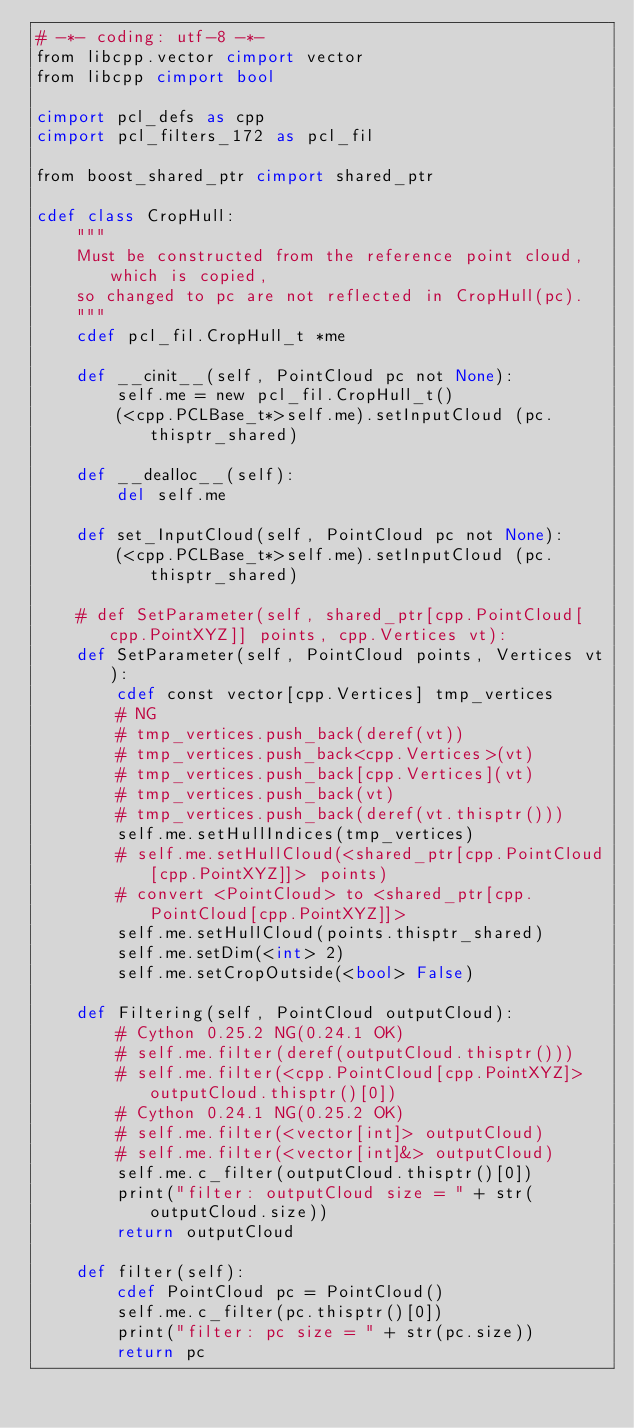<code> <loc_0><loc_0><loc_500><loc_500><_Cython_># -*- coding: utf-8 -*-
from libcpp.vector cimport vector
from libcpp cimport bool

cimport pcl_defs as cpp
cimport pcl_filters_172 as pcl_fil

from boost_shared_ptr cimport shared_ptr

cdef class CropHull:
    """
    Must be constructed from the reference point cloud, which is copied, 
    so changed to pc are not reflected in CropHull(pc).
    """
    cdef pcl_fil.CropHull_t *me

    def __cinit__(self, PointCloud pc not None):
        self.me = new pcl_fil.CropHull_t()
        (<cpp.PCLBase_t*>self.me).setInputCloud (pc.thisptr_shared)

    def __dealloc__(self):
        del self.me

    def set_InputCloud(self, PointCloud pc not None):
        (<cpp.PCLBase_t*>self.me).setInputCloud (pc.thisptr_shared)

    # def SetParameter(self, shared_ptr[cpp.PointCloud[cpp.PointXYZ]] points, cpp.Vertices vt):
    def SetParameter(self, PointCloud points, Vertices vt):
        cdef const vector[cpp.Vertices] tmp_vertices
        # NG
        # tmp_vertices.push_back(deref(vt))
        # tmp_vertices.push_back<cpp.Vertices>(vt)
        # tmp_vertices.push_back[cpp.Vertices](vt)
        # tmp_vertices.push_back(vt)
        # tmp_vertices.push_back(deref(vt.thisptr()))
        self.me.setHullIndices(tmp_vertices)
        # self.me.setHullCloud(<shared_ptr[cpp.PointCloud[cpp.PointXYZ]]> points)
        # convert <PointCloud> to <shared_ptr[cpp.PointCloud[cpp.PointXYZ]]>
        self.me.setHullCloud(points.thisptr_shared)
        self.me.setDim(<int> 2)
        self.me.setCropOutside(<bool> False)

    def Filtering(self, PointCloud outputCloud):
        # Cython 0.25.2 NG(0.24.1 OK)
        # self.me.filter(deref(outputCloud.thisptr()))
        # self.me.filter(<cpp.PointCloud[cpp.PointXYZ]> outputCloud.thisptr()[0])
        # Cython 0.24.1 NG(0.25.2 OK)
        # self.me.filter(<vector[int]> outputCloud)
        # self.me.filter(<vector[int]&> outputCloud)
        self.me.c_filter(outputCloud.thisptr()[0])
        print("filter: outputCloud size = " + str(outputCloud.size))
        return outputCloud

    def filter(self):
        cdef PointCloud pc = PointCloud()
        self.me.c_filter(pc.thisptr()[0])
        print("filter: pc size = " + str(pc.size))
        return pc


</code> 